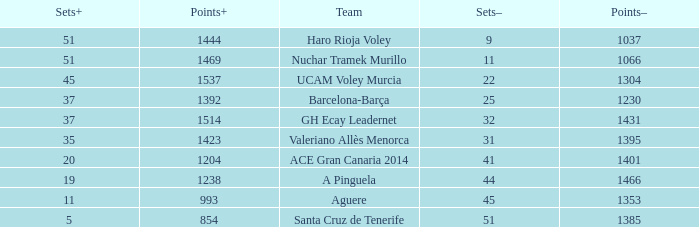What is the highest Points+ number when the Points- number is larger than 1385, a Sets+ number smaller than 37 and a Sets- number larger than 41? 1238.0. 